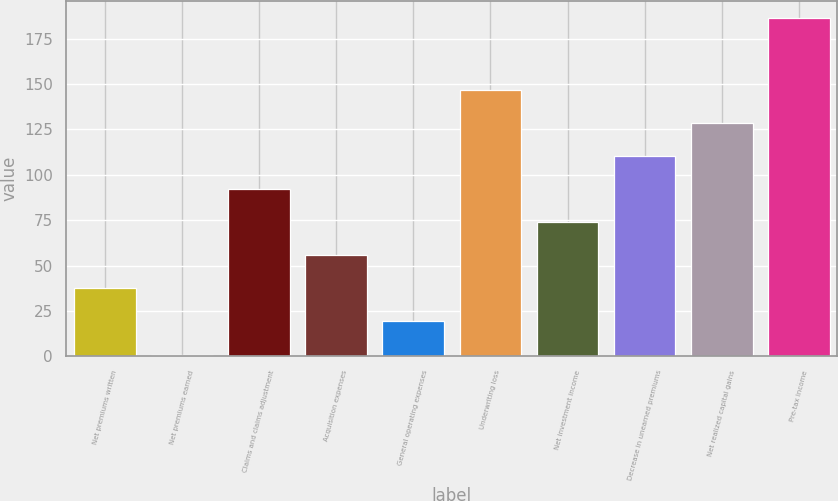Convert chart to OTSL. <chart><loc_0><loc_0><loc_500><loc_500><bar_chart><fcel>Net premiums written<fcel>Net premiums earned<fcel>Claims and claims adjustment<fcel>Acquisition expenses<fcel>General operating expenses<fcel>Underwriting loss<fcel>Net investment income<fcel>Decrease in unearned premiums<fcel>Net realized capital gains<fcel>Pre-tax income<nl><fcel>37.4<fcel>1<fcel>92<fcel>55.6<fcel>19.2<fcel>146.6<fcel>73.8<fcel>110.2<fcel>128.4<fcel>186.2<nl></chart> 